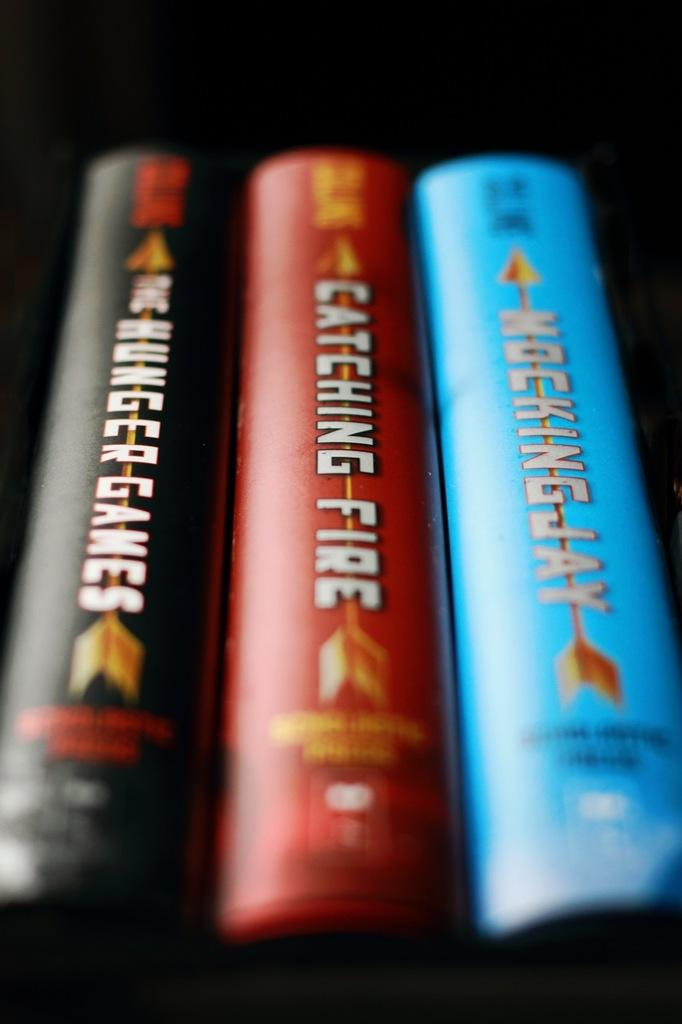<image>
Relay a brief, clear account of the picture shown. The Hunger Games, Catching Fire, and Mockingjay are the title of the three novels. 